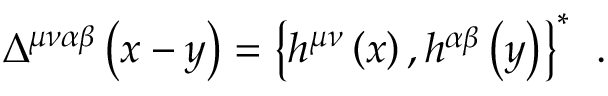<formula> <loc_0><loc_0><loc_500><loc_500>\Delta ^ { \mu \nu \alpha \beta } \left ( x - y \right ) = \left \{ h ^ { \mu \nu } \left ( x \right ) , h ^ { \alpha \beta } \left ( y \right ) \right \} ^ { * } \, .</formula> 